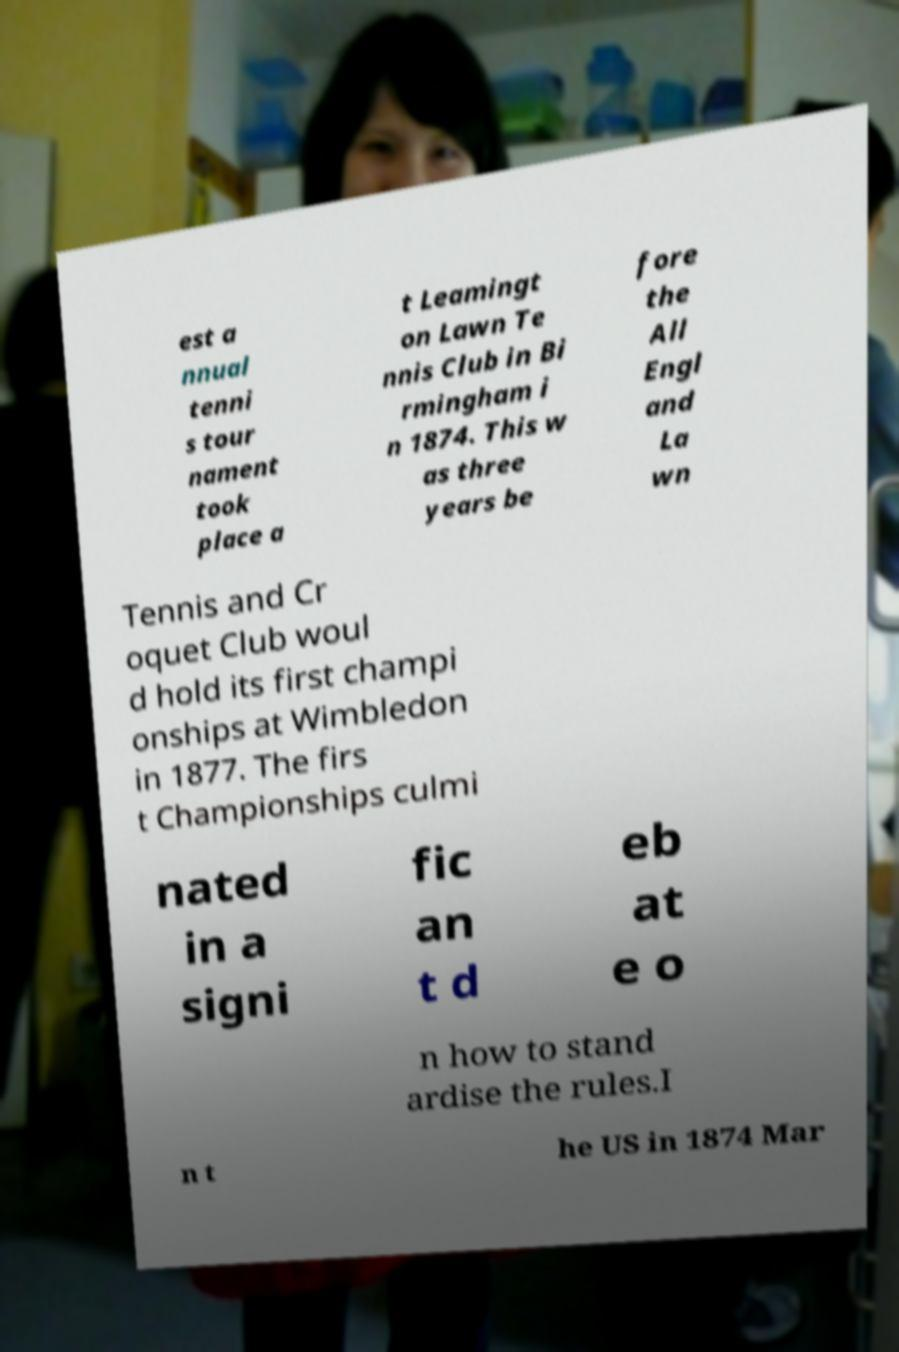Can you accurately transcribe the text from the provided image for me? est a nnual tenni s tour nament took place a t Leamingt on Lawn Te nnis Club in Bi rmingham i n 1874. This w as three years be fore the All Engl and La wn Tennis and Cr oquet Club woul d hold its first champi onships at Wimbledon in 1877. The firs t Championships culmi nated in a signi fic an t d eb at e o n how to stand ardise the rules.I n t he US in 1874 Mar 